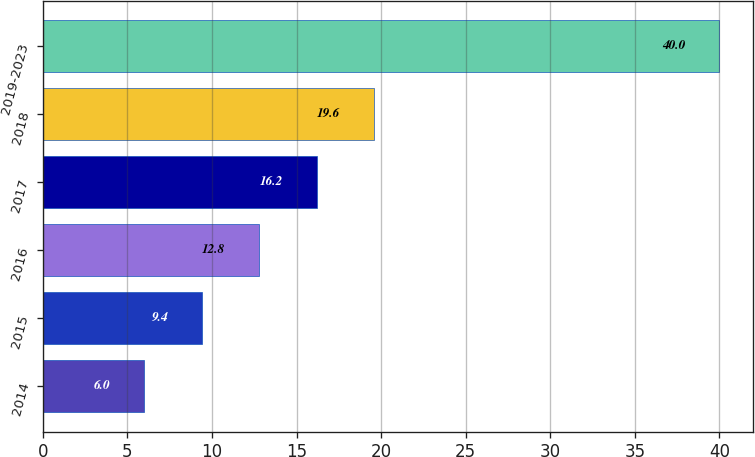Convert chart. <chart><loc_0><loc_0><loc_500><loc_500><bar_chart><fcel>2014<fcel>2015<fcel>2016<fcel>2017<fcel>2018<fcel>2019-2023<nl><fcel>6<fcel>9.4<fcel>12.8<fcel>16.2<fcel>19.6<fcel>40<nl></chart> 